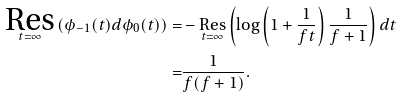Convert formula to latex. <formula><loc_0><loc_0><loc_500><loc_500>\underset { t = \infty } { \text {Res} } \left ( \phi _ { - 1 } ( t ) d \phi _ { 0 } ( t ) \right ) = & - \underset { t = \infty } { \text {Res} } \left ( \log \left ( 1 + \frac { 1 } { f t } \right ) \frac { 1 } { f + 1 } \right ) d t \\ = & \frac { 1 } { f ( f + 1 ) } .</formula> 